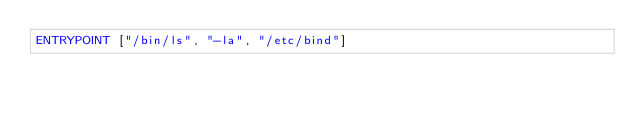Convert code to text. <code><loc_0><loc_0><loc_500><loc_500><_Dockerfile_>ENTRYPOINT ["/bin/ls", "-la", "/etc/bind"]
</code> 